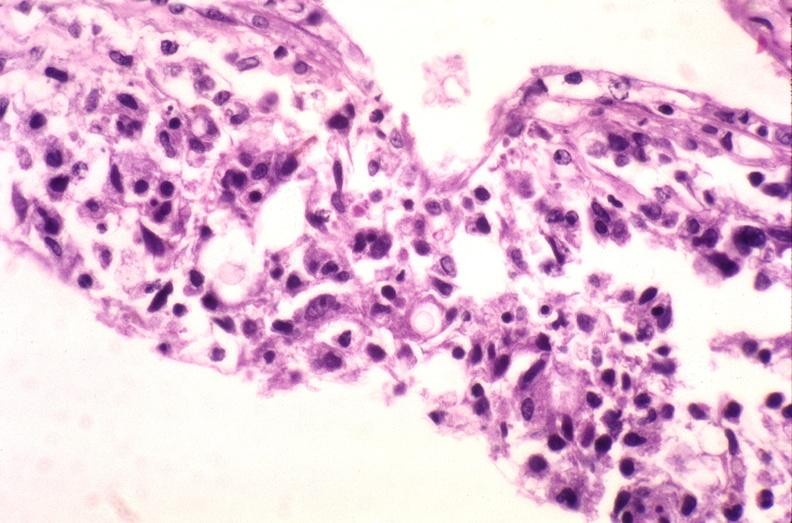does this image show brain, cryptococcal meningitis?
Answer the question using a single word or phrase. Yes 